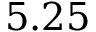<formula> <loc_0><loc_0><loc_500><loc_500>5 . 2 5</formula> 